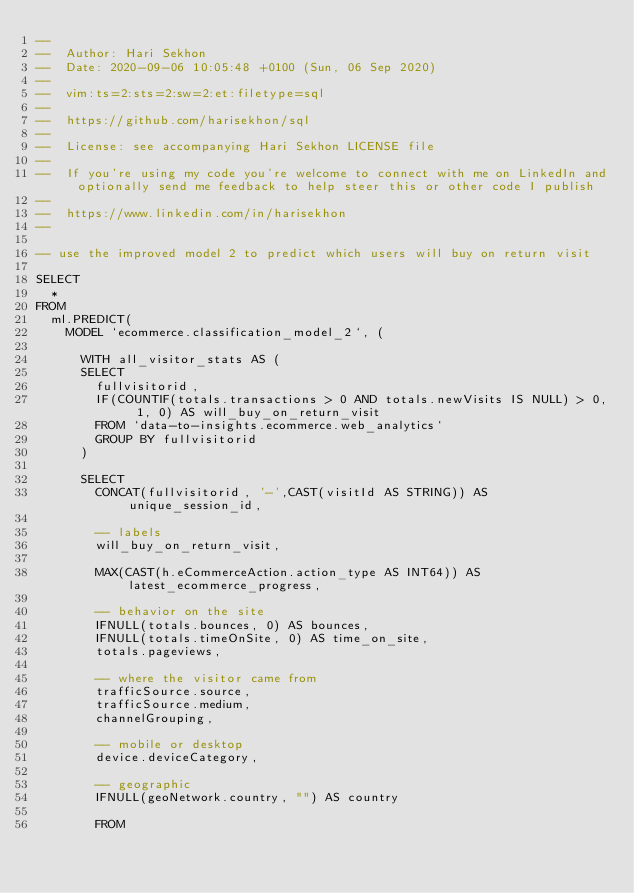Convert code to text. <code><loc_0><loc_0><loc_500><loc_500><_SQL_>--
--  Author: Hari Sekhon
--  Date: 2020-09-06 10:05:48 +0100 (Sun, 06 Sep 2020)
--
--  vim:ts=2:sts=2:sw=2:et:filetype=sql
--
--  https://github.com/harisekhon/sql
--
--  License: see accompanying Hari Sekhon LICENSE file
--
--  If you're using my code you're welcome to connect with me on LinkedIn and optionally send me feedback to help steer this or other code I publish
--
--  https://www.linkedin.com/in/harisekhon
--

-- use the improved model 2 to predict which users will buy on return visit

SELECT
  *
FROM
  ml.PREDICT(
    MODEL `ecommerce.classification_model_2`, (

      WITH all_visitor_stats AS (
      SELECT
        fullvisitorid,
        IF(COUNTIF(totals.transactions > 0 AND totals.newVisits IS NULL) > 0, 1, 0) AS will_buy_on_return_visit
        FROM `data-to-insights.ecommerce.web_analytics`
        GROUP BY fullvisitorid
      )

      SELECT
        CONCAT(fullvisitorid, '-',CAST(visitId AS STRING)) AS unique_session_id,

        -- labels
        will_buy_on_return_visit,

        MAX(CAST(h.eCommerceAction.action_type AS INT64)) AS latest_ecommerce_progress,

        -- behavior on the site
        IFNULL(totals.bounces, 0) AS bounces,
        IFNULL(totals.timeOnSite, 0) AS time_on_site,
        totals.pageviews,

        -- where the visitor came from
        trafficSource.source,
        trafficSource.medium,
        channelGrouping,

        -- mobile or desktop
        device.deviceCategory,

        -- geographic
        IFNULL(geoNetwork.country, "") AS country

        FROM</code> 